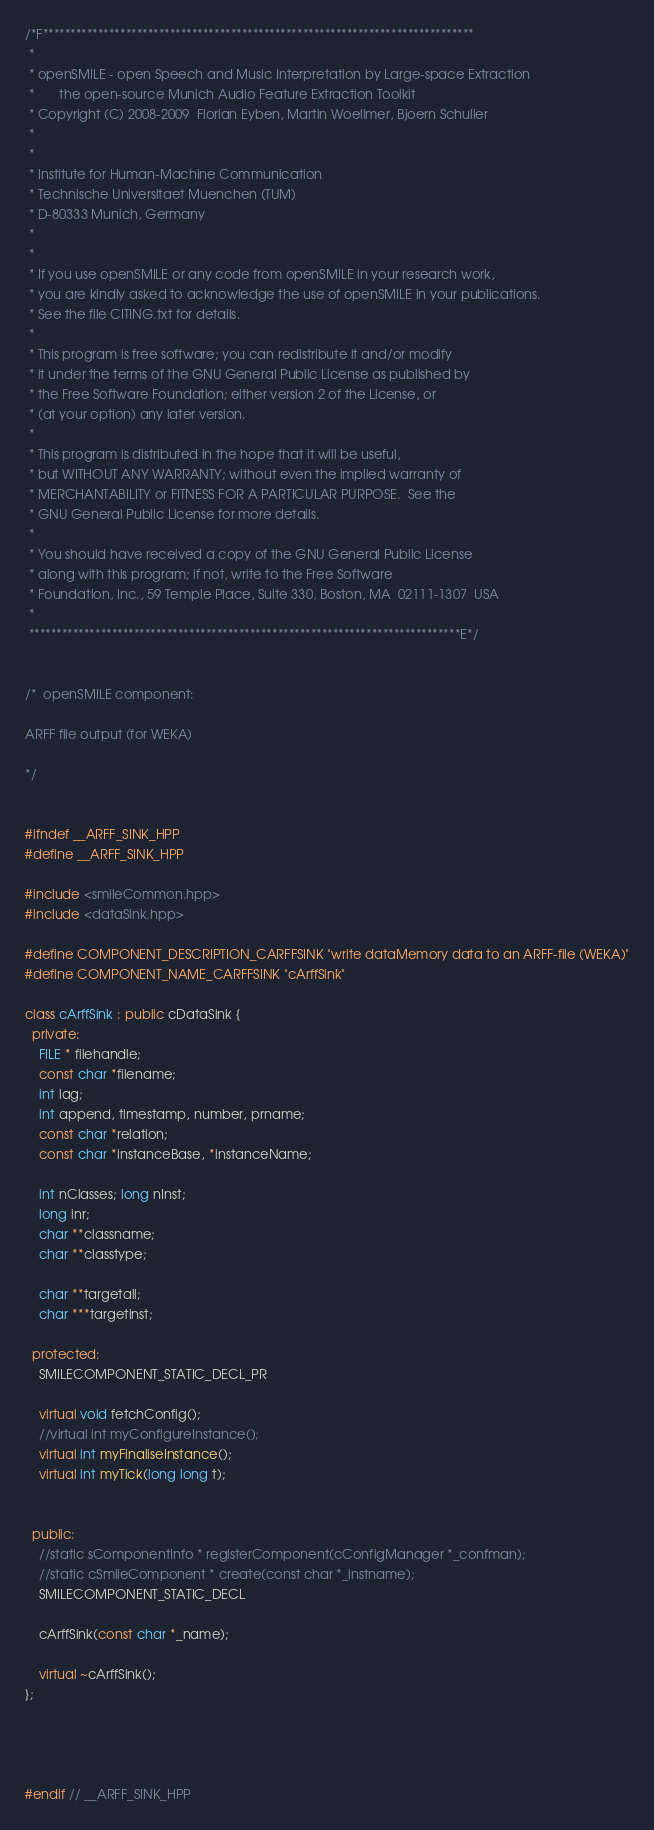<code> <loc_0><loc_0><loc_500><loc_500><_C++_>/*F******************************************************************************
 *
 * openSMILE - open Speech and Music Interpretation by Large-space Extraction
 *       the open-source Munich Audio Feature Extraction Toolkit
 * Copyright (C) 2008-2009  Florian Eyben, Martin Woellmer, Bjoern Schuller
 *
 *
 * Institute for Human-Machine Communication
 * Technische Universitaet Muenchen (TUM)
 * D-80333 Munich, Germany
 *
 *
 * If you use openSMILE or any code from openSMILE in your research work,
 * you are kindly asked to acknowledge the use of openSMILE in your publications.
 * See the file CITING.txt for details.
 *
 * This program is free software; you can redistribute it and/or modify
 * it under the terms of the GNU General Public License as published by
 * the Free Software Foundation; either version 2 of the License, or
 * (at your option) any later version.
 *
 * This program is distributed in the hope that it will be useful,
 * but WITHOUT ANY WARRANTY; without even the implied warranty of
 * MERCHANTABILITY or FITNESS FOR A PARTICULAR PURPOSE.  See the
 * GNU General Public License for more details.
 *
 * You should have received a copy of the GNU General Public License
 * along with this program; if not, write to the Free Software
 * Foundation, Inc., 59 Temple Place, Suite 330, Boston, MA  02111-1307  USA
 *
 ******************************************************************************E*/


/*  openSMILE component:

ARFF file output (for WEKA)

*/


#ifndef __ARFF_SINK_HPP
#define __ARFF_SINK_HPP

#include <smileCommon.hpp>
#include <dataSink.hpp>

#define COMPONENT_DESCRIPTION_CARFFSINK "write dataMemory data to an ARFF-file (WEKA)"
#define COMPONENT_NAME_CARFFSINK "cArffSink"

class cArffSink : public cDataSink {
  private:
    FILE * filehandle;
    const char *filename;
    int lag;
    int append, timestamp, number, prname;
    const char *relation;
    const char *instanceBase, *instanceName;
    
    int nClasses; long nInst;
    long inr;
    char **classname;
    char **classtype;
    
    char **targetall;
    char ***targetinst;
    
  protected:
    SMILECOMPONENT_STATIC_DECL_PR
    
    virtual void fetchConfig();
    //virtual int myConfigureInstance();
    virtual int myFinaliseInstance();
    virtual int myTick(long long t);


  public:
    //static sComponentInfo * registerComponent(cConfigManager *_confman);
    //static cSmileComponent * create(const char *_instname);
    SMILECOMPONENT_STATIC_DECL
    
    cArffSink(const char *_name);

    virtual ~cArffSink();
};




#endif // __ARFF_SINK_HPP
</code> 